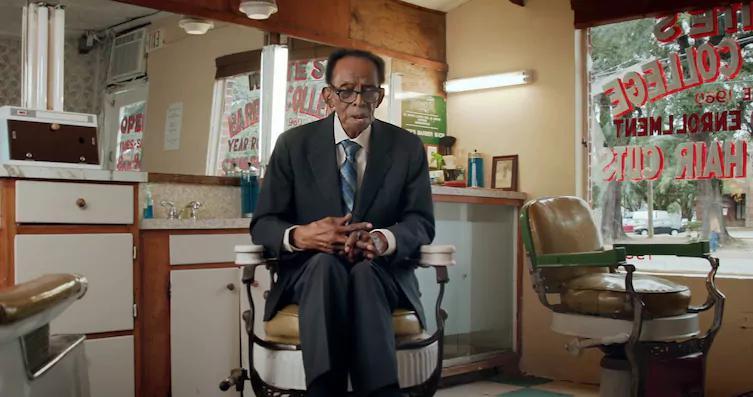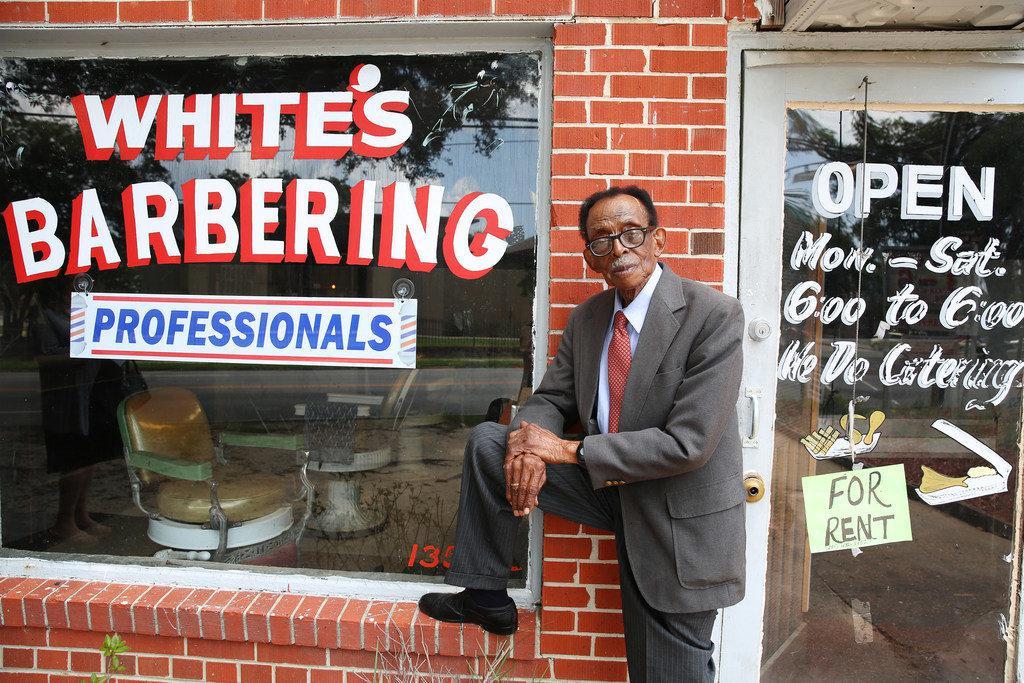The first image is the image on the left, the second image is the image on the right. Assess this claim about the two images: "In at least one image there is a single man in a suit and tie sitting in a barber chair.". Correct or not? Answer yes or no. Yes. The first image is the image on the left, the second image is the image on the right. Evaluate the accuracy of this statement regarding the images: "The left image shows an older black man in suit, tie and eyeglasses, sitting on a white barber chair.". Is it true? Answer yes or no. Yes. 